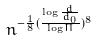Convert formula to latex. <formula><loc_0><loc_0><loc_500><loc_500>n ^ { - \frac { 1 } { 8 } ( \frac { \log \frac { d } { d _ { 0 } } } { \log \Pi } ) ^ { 8 } }</formula> 